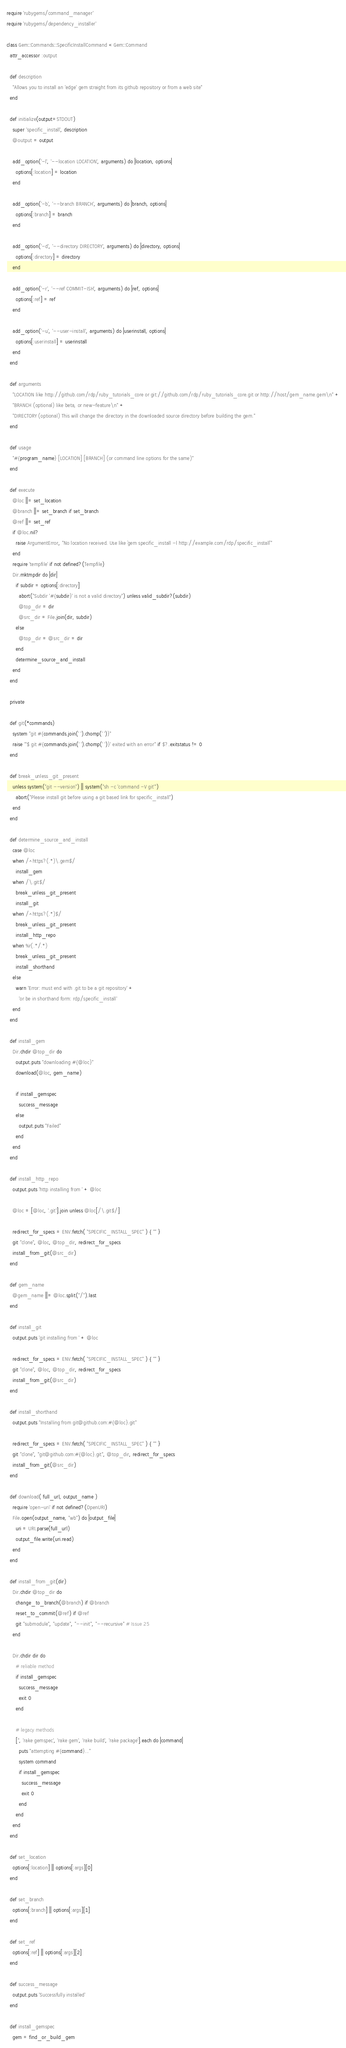<code> <loc_0><loc_0><loc_500><loc_500><_Ruby_>require 'rubygems/command_manager'
require 'rubygems/dependency_installer'

class Gem::Commands::SpecificInstallCommand < Gem::Command
  attr_accessor :output

  def description
    "Allows you to install an 'edge' gem straight from its github repository or from a web site"
  end

  def initialize(output=STDOUT)
    super 'specific_install', description
    @output = output

    add_option('-l', '--location LOCATION', arguments) do |location, options|
      options[:location] = location
    end

    add_option('-b', '--branch BRANCH', arguments) do |branch, options|
      options[:branch] = branch
    end

    add_option('-d', '--directory DIRECTORY', arguments) do |directory, options|
      options[:directory] = directory
    end

    add_option('-r', '--ref COMMIT-ISH', arguments) do |ref, options|
      options[:ref] = ref
    end

    add_option('-u', '--user-install', arguments) do |userinstall, options|
      options[:userinstall] = userinstall
    end
  end

  def arguments
    "LOCATION like http://github.com/rdp/ruby_tutorials_core or git://github.com/rdp/ruby_tutorials_core.git or http://host/gem_name.gem\n" +
    "BRANCH (optional) like beta, or new-feature\n" +
    "DIRECTORY (optional) This will change the directory in the downloaded source directory before building the gem."
  end

  def usage
    "#{program_name} [LOCATION] [BRANCH] (or command line options for the same)"
  end

  def execute
    @loc ||= set_location
    @branch ||= set_branch if set_branch
    @ref ||= set_ref
    if @loc.nil?
      raise ArgumentError, "No location received. Use like `gem specific_install -l http://example.com/rdp/specific_install`"
    end
    require 'tempfile' if not defined?(Tempfile)
    Dir.mktmpdir do |dir|
      if subdir = options[:directory]
        abort("Subdir '#{subdir}' is not a valid directory") unless valid_subdir?(subdir)
        @top_dir = dir
        @src_dir = File.join(dir, subdir)
      else
        @top_dir = @src_dir = dir
      end
      determine_source_and_install
    end
  end

  private

  def git(*commands)
    system "git #{commands.join(' ').chomp(' ')}"
    raise "'$ git #{commands.join(' ').chomp(' ')}' exited with an error" if $?.exitstatus != 0
  end

  def break_unless_git_present
    unless system("git --version") || system("sh -c 'command -V git'")
      abort("Please install git before using a git based link for specific_install")
    end
  end

  def determine_source_and_install
    case @loc
    when /^https?(.*)\.gem$/
      install_gem
    when /\.git$/
      break_unless_git_present
      install_git
    when /^https?(.*)$/
      break_unless_git_present
      install_http_repo
    when %r(.*/.*)
      break_unless_git_present
      install_shorthand
    else
      warn 'Error: must end with .git to be a git repository' +
        'or be in shorthand form: rdp/specific_install'
    end
  end

  def install_gem
    Dir.chdir @top_dir do
      output.puts "downloading #{@loc}"
      download(@loc, gem_name)

      if install_gemspec
        success_message
      else
        output.puts "Failed"
      end
    end
  end

  def install_http_repo
    output.puts 'http installing from ' + @loc

    @loc = [@loc, '.git'].join unless @loc[/\.git$/]

    redirect_for_specs = ENV.fetch( "SPECIFIC_INSTALL_SPEC" ) { "" }
    git "clone", @loc, @top_dir, redirect_for_specs
    install_from_git(@src_dir)
  end

  def gem_name
    @gem_name ||= @loc.split("/").last
  end

  def install_git
    output.puts 'git installing from ' + @loc

    redirect_for_specs = ENV.fetch( "SPECIFIC_INSTALL_SPEC" ) { "" }
    git "clone", @loc, @top_dir, redirect_for_specs
    install_from_git(@src_dir)
  end

  def install_shorthand
    output.puts "Installing from git@github.com:#{@loc}.git"

    redirect_for_specs = ENV.fetch( "SPECIFIC_INSTALL_SPEC" ) { "" }
    git "clone", "git@github.com:#{@loc}.git", @top_dir, redirect_for_specs
    install_from_git(@src_dir)
  end

  def download( full_url, output_name )
    require 'open-uri' if not defined?(OpenURI)
    File.open(output_name, "wb") do |output_file|
      uri = URI.parse(full_url)
      output_file.write(uri.read)
    end
  end

  def install_from_git(dir)
    Dir.chdir @top_dir do
      change_to_branch(@branch) if @branch
      reset_to_commit(@ref) if @ref
      git "submodule", "update", "--init", "--recursive" # Issue 25
    end

    Dir.chdir dir do
      # reliable method
      if install_gemspec
        success_message
        exit 0
      end

      # legacy methods
      ['', 'rake gemspec', 'rake gem', 'rake build', 'rake package'].each do |command|
        puts "attempting #{command}..."
        system command
        if install_gemspec
          success_message
          exit 0
        end
      end
    end
  end

  def set_location
    options[:location] || options[:args][0]
  end

  def set_branch
    options[:branch] || options[:args][1]
  end

  def set_ref
    options[:ref] || options[:args][2]
  end

  def success_message
    output.puts 'Successfully installed'
  end

  def install_gemspec
    gem = find_or_build_gem</code> 